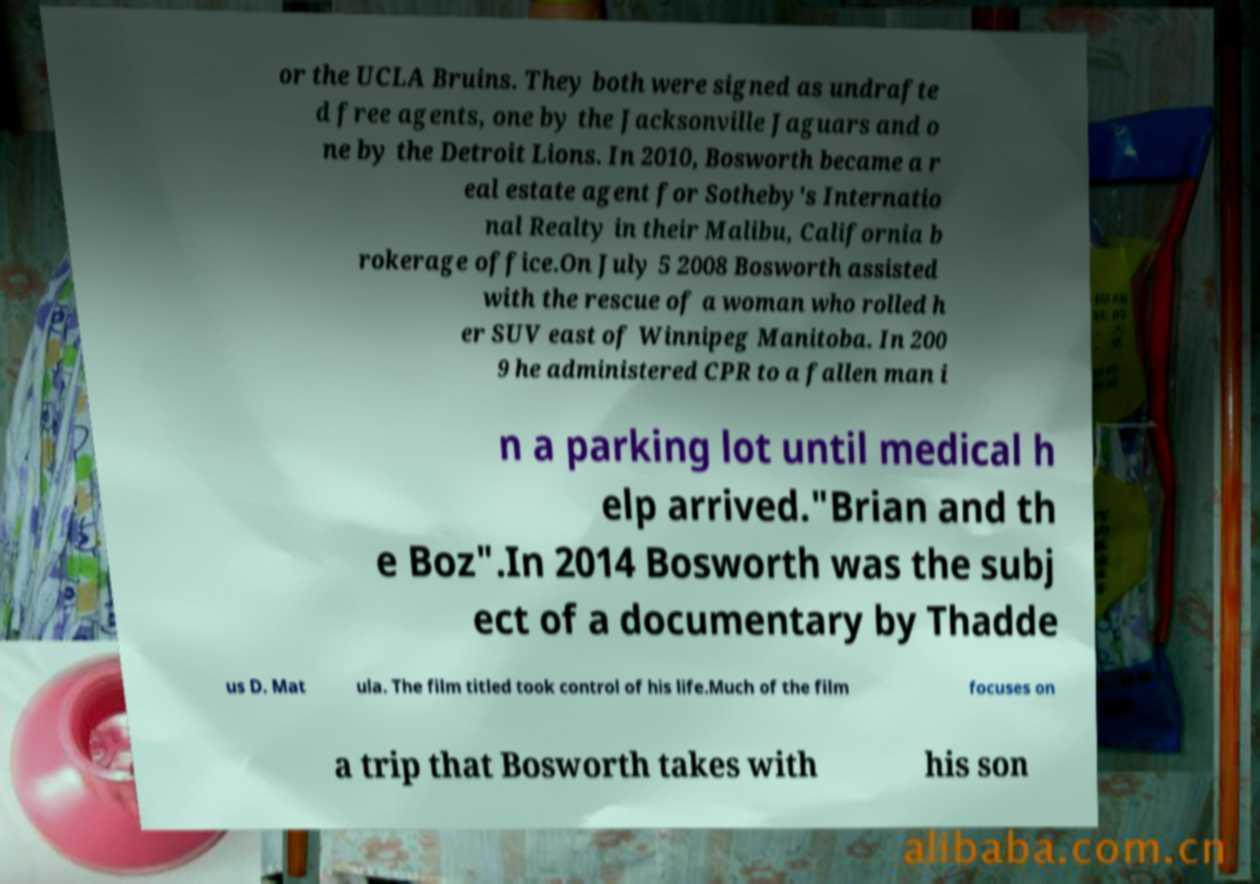Could you assist in decoding the text presented in this image and type it out clearly? or the UCLA Bruins. They both were signed as undrafte d free agents, one by the Jacksonville Jaguars and o ne by the Detroit Lions. In 2010, Bosworth became a r eal estate agent for Sotheby's Internatio nal Realty in their Malibu, California b rokerage office.On July 5 2008 Bosworth assisted with the rescue of a woman who rolled h er SUV east of Winnipeg Manitoba. In 200 9 he administered CPR to a fallen man i n a parking lot until medical h elp arrived."Brian and th e Boz".In 2014 Bosworth was the subj ect of a documentary by Thadde us D. Mat ula. The film titled took control of his life.Much of the film focuses on a trip that Bosworth takes with his son 